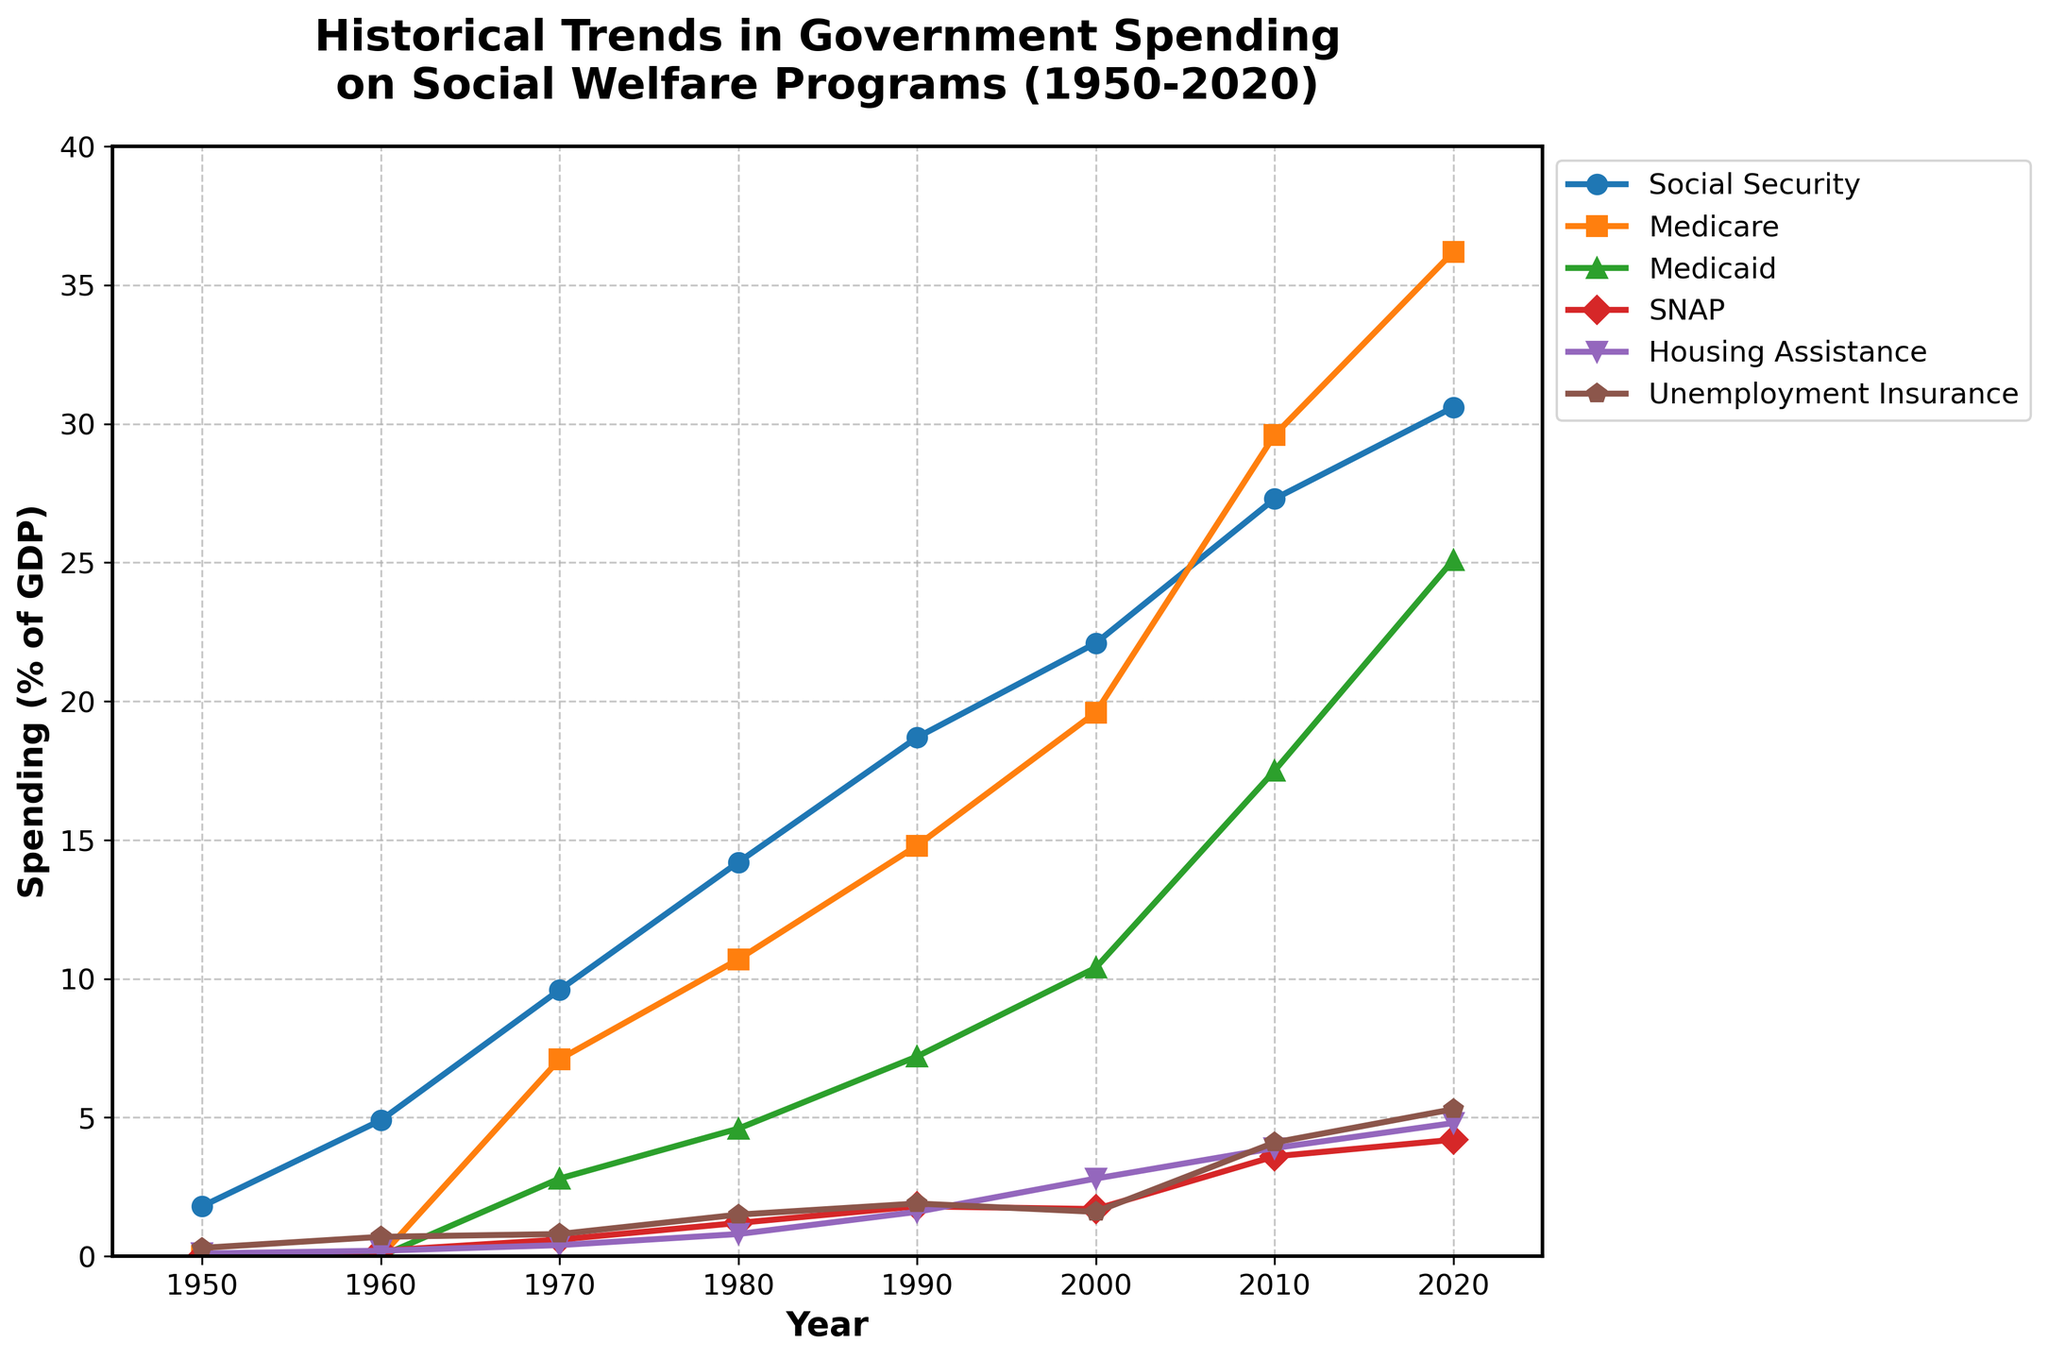What is the trend in government spending on Social Security from 1950 to 2020? The line representing Social Security spending starts at 1.8% in 1950 and steadily increases to 30.6% in 2020. This indicates an upward trend over the years.
Answer: Upward trend Which program had the highest spending percentage in 2020? In 2020, comparing the endpoints of all lines, Medicare had the highest spending percentage at 36.2%, which is higher than Social Security (30.6%) and other programs.
Answer: Medicare Between 1960 and 1970, which program had the most significant increase in spending percentage? By comparing the difference in values between 1970 and 1960 for each program, Social Security increased from 4.9% to 9.6%, Medicare from 0% to 7.1%, and Medicaid from 0% to 2.8%. Medicare had the most significant increase of 7.1%.
Answer: Medicare What is the average percentage of GDP spent on Unemployment Insurance from 1950 to 2020? Average = (1.8 + 0.7 + 0.8 + 1.5 + 1.9 + 1.6 + 4.1 + 5.3) / 8 = 18.7 / 8
Answer: 2.3% In 1980, which program had the lowest spending percentage, and what was it? In 1980, comparing the values for each program, Housing Assistance at 0.8% was the lowest, lower than Social Security, Medicare, Medicaid, SNAP, and Unemployment Insurance.
Answer: Housing Assistance, 0.8% How does the spending on Medicaid in 2020 compare with the spending on SNAP in the same year? In 2020, Medicaid spending was at 25.1%, and SNAP was at 4.2%. Medicaid spending was significantly higher.
Answer: Medicaid is higher What is the difference in spending percentage on Medicare between 2000 and 2010? Difference = Medicare percentage in 2010 - Medicare percentage in 2000 = 29.6% - 19.6% = 10%
Answer: 10% Which two programs show the most volatile trends over the years in terms of spending percentage? By visually inspecting the lines, Social Security and Medicare show the most significant changes in their slopes over the years, indicating more variability compared to other programs.
Answer: Social Security and Medicare In which decade did spending on SNAP see the most considerable increase? The biggest change in SNAP spending occurred between 2000 (1.7%) and 2010 (3.6%), an increase of 1.9%.
Answer: 2000-2010 Compare the spending on Housing Assistance and SNAP in 1990. Which one was higher? In 1990, Housing Assistance was at 1.6%, and SNAP was at 1.8%. SNAP was slightly higher.
Answer: SNAP 